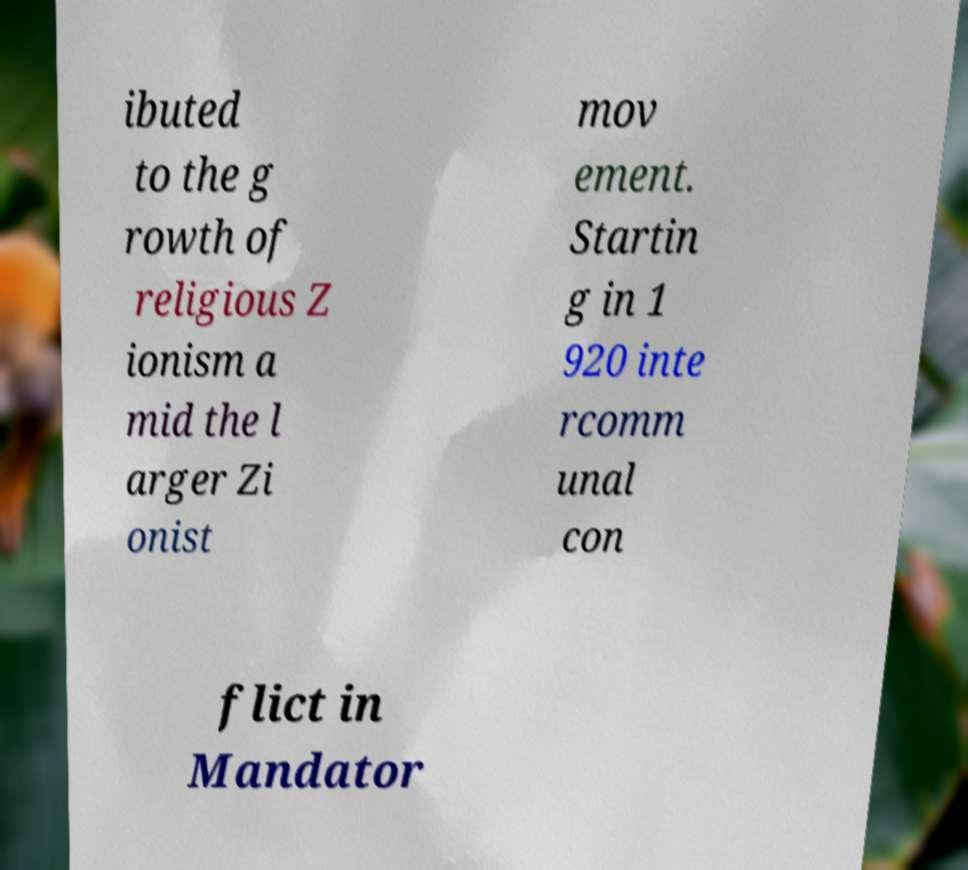What messages or text are displayed in this image? I need them in a readable, typed format. ibuted to the g rowth of religious Z ionism a mid the l arger Zi onist mov ement. Startin g in 1 920 inte rcomm unal con flict in Mandator 